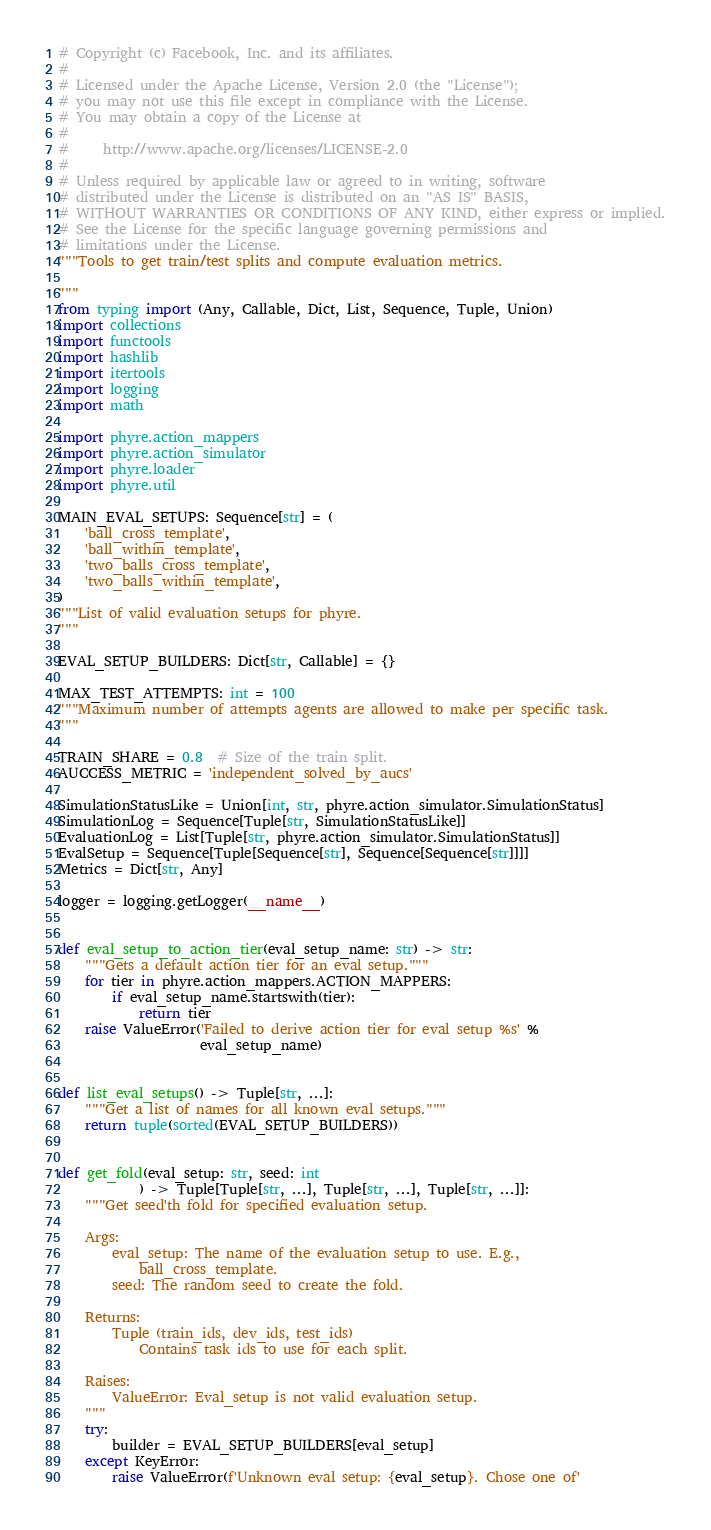<code> <loc_0><loc_0><loc_500><loc_500><_Python_># Copyright (c) Facebook, Inc. and its affiliates.
#
# Licensed under the Apache License, Version 2.0 (the "License");
# you may not use this file except in compliance with the License.
# You may obtain a copy of the License at
#
#     http://www.apache.org/licenses/LICENSE-2.0
#
# Unless required by applicable law or agreed to in writing, software
# distributed under the License is distributed on an "AS IS" BASIS,
# WITHOUT WARRANTIES OR CONDITIONS OF ANY KIND, either express or implied.
# See the License for the specific language governing permissions and
# limitations under the License.
"""Tools to get train/test splits and compute evaluation metrics.

"""
from typing import (Any, Callable, Dict, List, Sequence, Tuple, Union)
import collections
import functools
import hashlib
import itertools
import logging
import math

import phyre.action_mappers
import phyre.action_simulator
import phyre.loader
import phyre.util

MAIN_EVAL_SETUPS: Sequence[str] = (
    'ball_cross_template',
    'ball_within_template',
    'two_balls_cross_template',
    'two_balls_within_template',
)
"""List of valid evaluation setups for phyre.
"""

EVAL_SETUP_BUILDERS: Dict[str, Callable] = {}

MAX_TEST_ATTEMPTS: int = 100
"""Maximum number of attempts agents are allowed to make per specific task.
"""

TRAIN_SHARE = 0.8  # Size of the train split.
AUCCESS_METRIC = 'independent_solved_by_aucs'

SimulationStatusLike = Union[int, str, phyre.action_simulator.SimulationStatus]
SimulationLog = Sequence[Tuple[str, SimulationStatusLike]]
EvaluationLog = List[Tuple[str, phyre.action_simulator.SimulationStatus]]
EvalSetup = Sequence[Tuple[Sequence[str], Sequence[Sequence[str]]]]
Metrics = Dict[str, Any]

logger = logging.getLogger(__name__)


def eval_setup_to_action_tier(eval_setup_name: str) -> str:
    """Gets a default action tier for an eval setup."""
    for tier in phyre.action_mappers.ACTION_MAPPERS:
        if eval_setup_name.startswith(tier):
            return tier
    raise ValueError('Failed to derive action tier for eval setup %s' %
                     eval_setup_name)


def list_eval_setups() -> Tuple[str, ...]:
    """Get a list of names for all known eval setups."""
    return tuple(sorted(EVAL_SETUP_BUILDERS))


def get_fold(eval_setup: str, seed: int
            ) -> Tuple[Tuple[str, ...], Tuple[str, ...], Tuple[str, ...]]:
    """Get seed'th fold for specified evaluation setup.

    Args:
        eval_setup: The name of the evaluation setup to use. E.g.,
            ball_cross_template.
        seed: The random seed to create the fold.

    Returns:
        Tuple (train_ids, dev_ids, test_ids)
            Contains task ids to use for each split.

    Raises:
        ValueError: Eval_setup is not valid evaluation setup.
    """
    try:
        builder = EVAL_SETUP_BUILDERS[eval_setup]
    except KeyError:
        raise ValueError(f'Unknown eval setup: {eval_setup}. Chose one of'</code> 